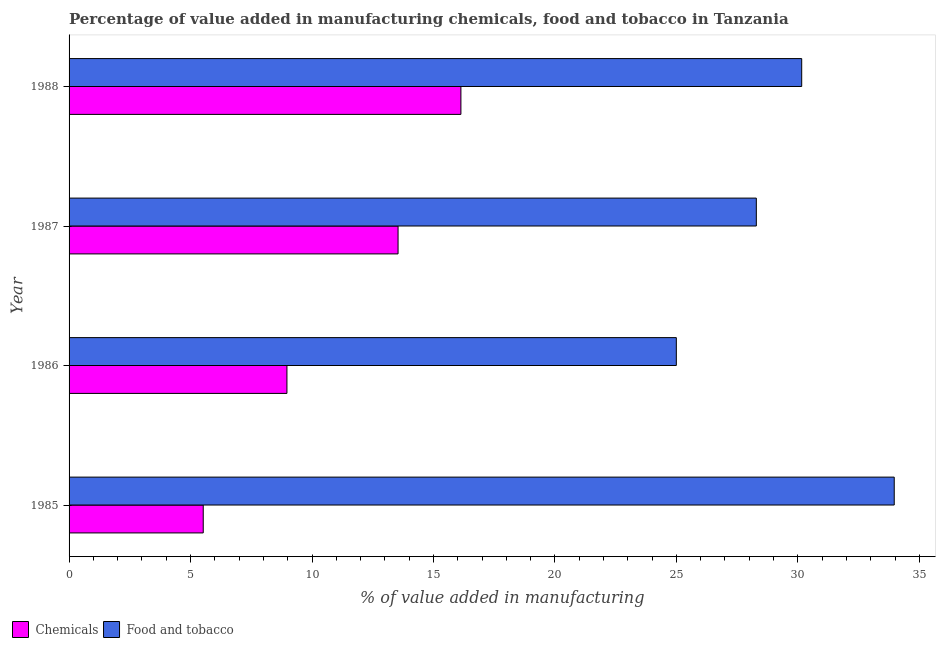How many different coloured bars are there?
Your response must be concise. 2. How many groups of bars are there?
Offer a very short reply. 4. Are the number of bars per tick equal to the number of legend labels?
Your response must be concise. Yes. Are the number of bars on each tick of the Y-axis equal?
Keep it short and to the point. Yes. How many bars are there on the 1st tick from the top?
Offer a very short reply. 2. In how many cases, is the number of bars for a given year not equal to the number of legend labels?
Ensure brevity in your answer.  0. What is the value added by manufacturing food and tobacco in 1987?
Offer a very short reply. 28.29. Across all years, what is the maximum value added by manufacturing food and tobacco?
Your answer should be very brief. 33.97. Across all years, what is the minimum value added by  manufacturing chemicals?
Give a very brief answer. 5.52. In which year was the value added by  manufacturing chemicals maximum?
Provide a succinct answer. 1988. What is the total value added by  manufacturing chemicals in the graph?
Provide a short and direct response. 44.16. What is the difference between the value added by  manufacturing chemicals in 1987 and that in 1988?
Keep it short and to the point. -2.59. What is the difference between the value added by manufacturing food and tobacco in 1987 and the value added by  manufacturing chemicals in 1986?
Offer a very short reply. 19.32. What is the average value added by manufacturing food and tobacco per year?
Make the answer very short. 29.35. In the year 1986, what is the difference between the value added by manufacturing food and tobacco and value added by  manufacturing chemicals?
Offer a terse response. 16.03. What is the ratio of the value added by  manufacturing chemicals in 1987 to that in 1988?
Give a very brief answer. 0.84. Is the value added by  manufacturing chemicals in 1985 less than that in 1987?
Offer a very short reply. Yes. What is the difference between the highest and the second highest value added by  manufacturing chemicals?
Your answer should be very brief. 2.59. What is the difference between the highest and the lowest value added by  manufacturing chemicals?
Make the answer very short. 10.61. Is the sum of the value added by  manufacturing chemicals in 1985 and 1986 greater than the maximum value added by manufacturing food and tobacco across all years?
Provide a short and direct response. No. What does the 2nd bar from the top in 1985 represents?
Make the answer very short. Chemicals. What does the 2nd bar from the bottom in 1986 represents?
Your answer should be very brief. Food and tobacco. How many bars are there?
Give a very brief answer. 8. Are all the bars in the graph horizontal?
Provide a succinct answer. Yes. What is the difference between two consecutive major ticks on the X-axis?
Offer a very short reply. 5. Does the graph contain grids?
Provide a short and direct response. No. Where does the legend appear in the graph?
Give a very brief answer. Bottom left. How many legend labels are there?
Your response must be concise. 2. What is the title of the graph?
Offer a very short reply. Percentage of value added in manufacturing chemicals, food and tobacco in Tanzania. Does "Transport services" appear as one of the legend labels in the graph?
Provide a succinct answer. No. What is the label or title of the X-axis?
Make the answer very short. % of value added in manufacturing. What is the label or title of the Y-axis?
Provide a succinct answer. Year. What is the % of value added in manufacturing of Chemicals in 1985?
Make the answer very short. 5.52. What is the % of value added in manufacturing of Food and tobacco in 1985?
Give a very brief answer. 33.97. What is the % of value added in manufacturing in Chemicals in 1986?
Provide a short and direct response. 8.97. What is the % of value added in manufacturing in Food and tobacco in 1986?
Make the answer very short. 25. What is the % of value added in manufacturing in Chemicals in 1987?
Your answer should be compact. 13.54. What is the % of value added in manufacturing in Food and tobacco in 1987?
Offer a very short reply. 28.29. What is the % of value added in manufacturing in Chemicals in 1988?
Offer a very short reply. 16.13. What is the % of value added in manufacturing of Food and tobacco in 1988?
Your answer should be compact. 30.16. Across all years, what is the maximum % of value added in manufacturing of Chemicals?
Your answer should be compact. 16.13. Across all years, what is the maximum % of value added in manufacturing in Food and tobacco?
Provide a short and direct response. 33.97. Across all years, what is the minimum % of value added in manufacturing of Chemicals?
Ensure brevity in your answer.  5.52. Across all years, what is the minimum % of value added in manufacturing in Food and tobacco?
Provide a succinct answer. 25. What is the total % of value added in manufacturing in Chemicals in the graph?
Make the answer very short. 44.16. What is the total % of value added in manufacturing of Food and tobacco in the graph?
Your response must be concise. 117.41. What is the difference between the % of value added in manufacturing in Chemicals in 1985 and that in 1986?
Your answer should be very brief. -3.45. What is the difference between the % of value added in manufacturing in Food and tobacco in 1985 and that in 1986?
Keep it short and to the point. 8.97. What is the difference between the % of value added in manufacturing in Chemicals in 1985 and that in 1987?
Ensure brevity in your answer.  -8.02. What is the difference between the % of value added in manufacturing in Food and tobacco in 1985 and that in 1987?
Your response must be concise. 5.68. What is the difference between the % of value added in manufacturing of Chemicals in 1985 and that in 1988?
Provide a succinct answer. -10.61. What is the difference between the % of value added in manufacturing in Food and tobacco in 1985 and that in 1988?
Ensure brevity in your answer.  3.81. What is the difference between the % of value added in manufacturing of Chemicals in 1986 and that in 1987?
Your response must be concise. -4.57. What is the difference between the % of value added in manufacturing of Food and tobacco in 1986 and that in 1987?
Ensure brevity in your answer.  -3.29. What is the difference between the % of value added in manufacturing in Chemicals in 1986 and that in 1988?
Ensure brevity in your answer.  -7.16. What is the difference between the % of value added in manufacturing in Food and tobacco in 1986 and that in 1988?
Ensure brevity in your answer.  -5.16. What is the difference between the % of value added in manufacturing in Chemicals in 1987 and that in 1988?
Provide a succinct answer. -2.59. What is the difference between the % of value added in manufacturing of Food and tobacco in 1987 and that in 1988?
Offer a very short reply. -1.87. What is the difference between the % of value added in manufacturing of Chemicals in 1985 and the % of value added in manufacturing of Food and tobacco in 1986?
Make the answer very short. -19.47. What is the difference between the % of value added in manufacturing of Chemicals in 1985 and the % of value added in manufacturing of Food and tobacco in 1987?
Offer a terse response. -22.77. What is the difference between the % of value added in manufacturing of Chemicals in 1985 and the % of value added in manufacturing of Food and tobacco in 1988?
Your response must be concise. -24.64. What is the difference between the % of value added in manufacturing of Chemicals in 1986 and the % of value added in manufacturing of Food and tobacco in 1987?
Give a very brief answer. -19.32. What is the difference between the % of value added in manufacturing in Chemicals in 1986 and the % of value added in manufacturing in Food and tobacco in 1988?
Your response must be concise. -21.19. What is the difference between the % of value added in manufacturing in Chemicals in 1987 and the % of value added in manufacturing in Food and tobacco in 1988?
Offer a very short reply. -16.62. What is the average % of value added in manufacturing of Chemicals per year?
Keep it short and to the point. 11.04. What is the average % of value added in manufacturing of Food and tobacco per year?
Ensure brevity in your answer.  29.35. In the year 1985, what is the difference between the % of value added in manufacturing in Chemicals and % of value added in manufacturing in Food and tobacco?
Provide a short and direct response. -28.44. In the year 1986, what is the difference between the % of value added in manufacturing in Chemicals and % of value added in manufacturing in Food and tobacco?
Offer a very short reply. -16.03. In the year 1987, what is the difference between the % of value added in manufacturing in Chemicals and % of value added in manufacturing in Food and tobacco?
Ensure brevity in your answer.  -14.75. In the year 1988, what is the difference between the % of value added in manufacturing of Chemicals and % of value added in manufacturing of Food and tobacco?
Give a very brief answer. -14.03. What is the ratio of the % of value added in manufacturing of Chemicals in 1985 to that in 1986?
Keep it short and to the point. 0.62. What is the ratio of the % of value added in manufacturing of Food and tobacco in 1985 to that in 1986?
Your answer should be very brief. 1.36. What is the ratio of the % of value added in manufacturing of Chemicals in 1985 to that in 1987?
Give a very brief answer. 0.41. What is the ratio of the % of value added in manufacturing of Food and tobacco in 1985 to that in 1987?
Your response must be concise. 1.2. What is the ratio of the % of value added in manufacturing in Chemicals in 1985 to that in 1988?
Ensure brevity in your answer.  0.34. What is the ratio of the % of value added in manufacturing in Food and tobacco in 1985 to that in 1988?
Your response must be concise. 1.13. What is the ratio of the % of value added in manufacturing in Chemicals in 1986 to that in 1987?
Ensure brevity in your answer.  0.66. What is the ratio of the % of value added in manufacturing of Food and tobacco in 1986 to that in 1987?
Ensure brevity in your answer.  0.88. What is the ratio of the % of value added in manufacturing in Chemicals in 1986 to that in 1988?
Offer a very short reply. 0.56. What is the ratio of the % of value added in manufacturing in Food and tobacco in 1986 to that in 1988?
Make the answer very short. 0.83. What is the ratio of the % of value added in manufacturing in Chemicals in 1987 to that in 1988?
Provide a succinct answer. 0.84. What is the ratio of the % of value added in manufacturing of Food and tobacco in 1987 to that in 1988?
Give a very brief answer. 0.94. What is the difference between the highest and the second highest % of value added in manufacturing of Chemicals?
Make the answer very short. 2.59. What is the difference between the highest and the second highest % of value added in manufacturing of Food and tobacco?
Your answer should be very brief. 3.81. What is the difference between the highest and the lowest % of value added in manufacturing of Chemicals?
Offer a very short reply. 10.61. What is the difference between the highest and the lowest % of value added in manufacturing of Food and tobacco?
Ensure brevity in your answer.  8.97. 